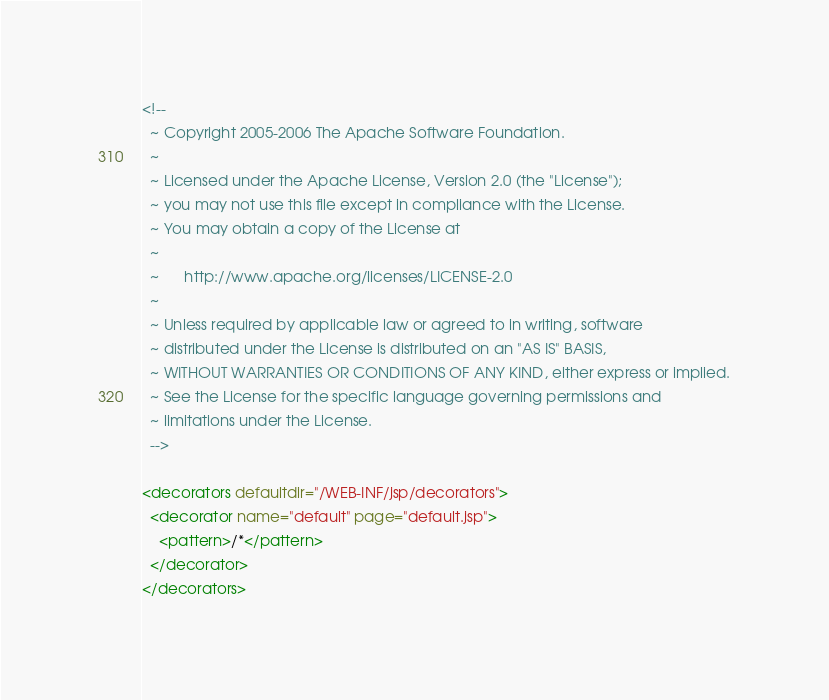<code> <loc_0><loc_0><loc_500><loc_500><_XML_><!--
  ~ Copyright 2005-2006 The Apache Software Foundation.
  ~
  ~ Licensed under the Apache License, Version 2.0 (the "License");
  ~ you may not use this file except in compliance with the License.
  ~ You may obtain a copy of the License at
  ~
  ~      http://www.apache.org/licenses/LICENSE-2.0
  ~
  ~ Unless required by applicable law or agreed to in writing, software
  ~ distributed under the License is distributed on an "AS IS" BASIS,
  ~ WITHOUT WARRANTIES OR CONDITIONS OF ANY KIND, either express or implied.
  ~ See the License for the specific language governing permissions and
  ~ limitations under the License.
  -->

<decorators defaultdir="/WEB-INF/jsp/decorators">
  <decorator name="default" page="default.jsp">
    <pattern>/*</pattern>
  </decorator>
</decorators></code> 